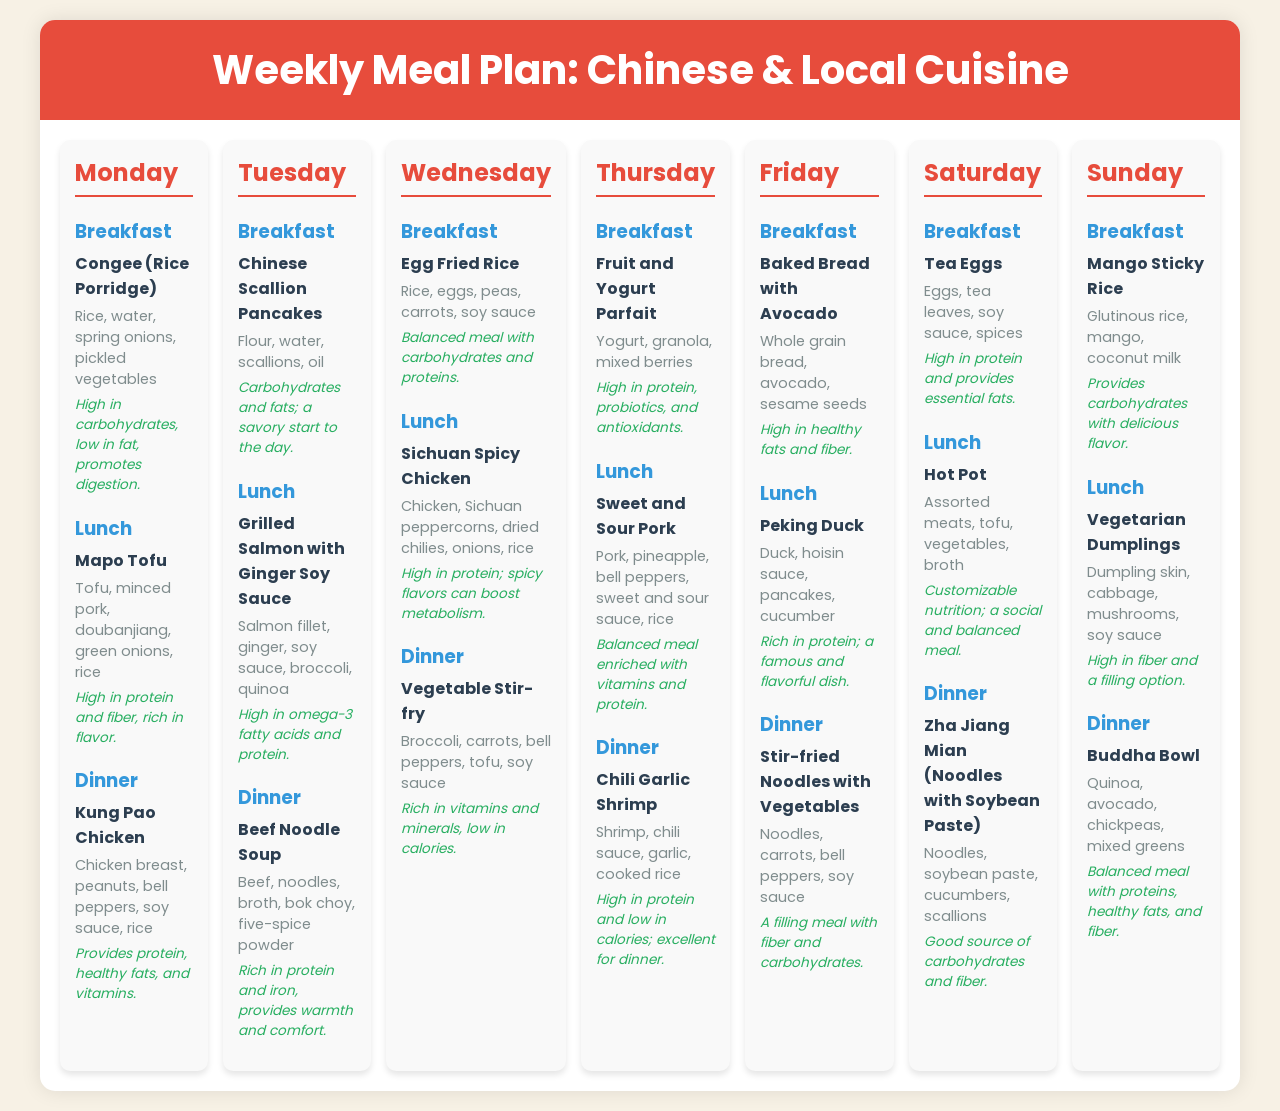What is served for breakfast on Monday? Monday's breakfast consists of congee, which includes rice, water, spring onions, and pickled vegetables.
Answer: Congee What is a key ingredient in Mapo Tofu? The lunch dish Mapo Tofu includes tofu as a key ingredient along with minced pork, doubanjiang, green onions, and rice.
Answer: Tofu How many meals are included for each day? Each day features three meals: breakfast, lunch, and dinner.
Answer: Three meals Which dish is high in omega-3 fatty acids? The lunch option on Tuesday, Grilled Salmon with Ginger Soy Sauce, is high in omega-3 fatty acids.
Answer: Grilled Salmon with Ginger Soy Sauce What type of cuisine does the meal plan primarily focus on? The meal plan primarily focuses on traditional Chinese cuisine along with local cuisine options.
Answer: Traditional Chinese cuisine How is the Vegetable Stir-fry characterized nutritionally? The Vegetable Stir-fry is rich in vitamins and minerals, and low in calories.
Answer: Rich in vitamins and minerals, low in calories What is the primary source of protein in the Buddha Bowl? The Buddha Bowl includes chickpeas as a primary source of protein along with quinoa, avocado, and mixed greens.
Answer: Chickpeas What dish provides a customizable nutrition experience? The lunch option on Saturday, Hot Pot, offers a customizable nutrition experience.
Answer: Hot Pot How is the Sichuan Spicy Chicken described in terms of protein? Sichuan Spicy Chicken is characterized as high in protein and can boost metabolism due to its spicy flavors.
Answer: High in protein 